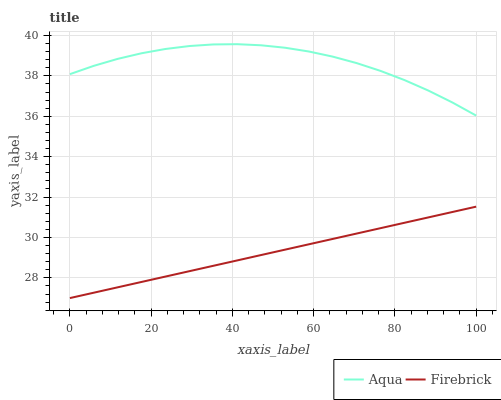Does Firebrick have the minimum area under the curve?
Answer yes or no. Yes. Does Aqua have the maximum area under the curve?
Answer yes or no. Yes. Does Aqua have the minimum area under the curve?
Answer yes or no. No. Is Firebrick the smoothest?
Answer yes or no. Yes. Is Aqua the roughest?
Answer yes or no. Yes. Is Aqua the smoothest?
Answer yes or no. No. Does Firebrick have the lowest value?
Answer yes or no. Yes. Does Aqua have the lowest value?
Answer yes or no. No. Does Aqua have the highest value?
Answer yes or no. Yes. Is Firebrick less than Aqua?
Answer yes or no. Yes. Is Aqua greater than Firebrick?
Answer yes or no. Yes. Does Firebrick intersect Aqua?
Answer yes or no. No. 